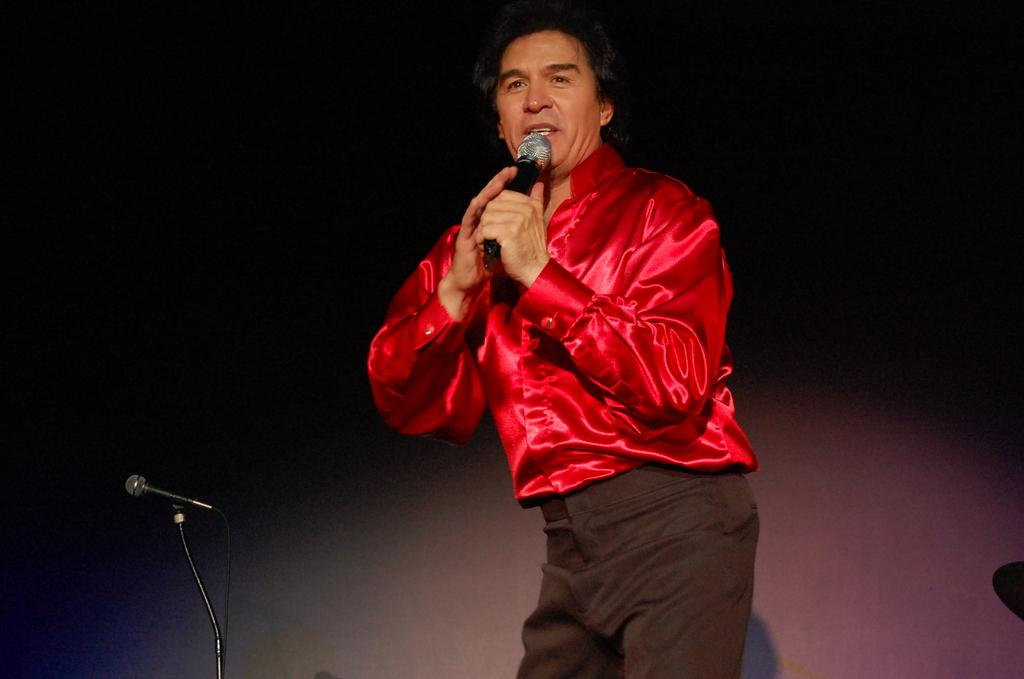What is the main subject of the image? There is a man in the image. What is the man wearing? The man is wearing a red shirt. What is the man doing in the image? The man is standing and appears to be singing a song. What object is the man holding in his hand? The man is holding a microphone in his hand. What can be seen on the left side of the image? There is a microphone stand on the left side of the image. How many rabbits are hopping around the man in the image? There are no rabbits present in the image. What fact can be learned about the store from the image? The image does not provide any information about a store. 